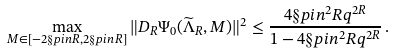Convert formula to latex. <formula><loc_0><loc_0><loc_500><loc_500>\max _ { M \in [ - 2 \S p i n R , 2 \S p i n R ] } \| D _ { R } \Psi _ { 0 } ( \widetilde { \Lambda } _ { R } , M ) \| ^ { 2 } \leq \frac { 4 \S p i n ^ { 2 } R q ^ { 2 R } } { 1 - 4 \S p i n ^ { 2 } R q ^ { 2 R } } \, .</formula> 